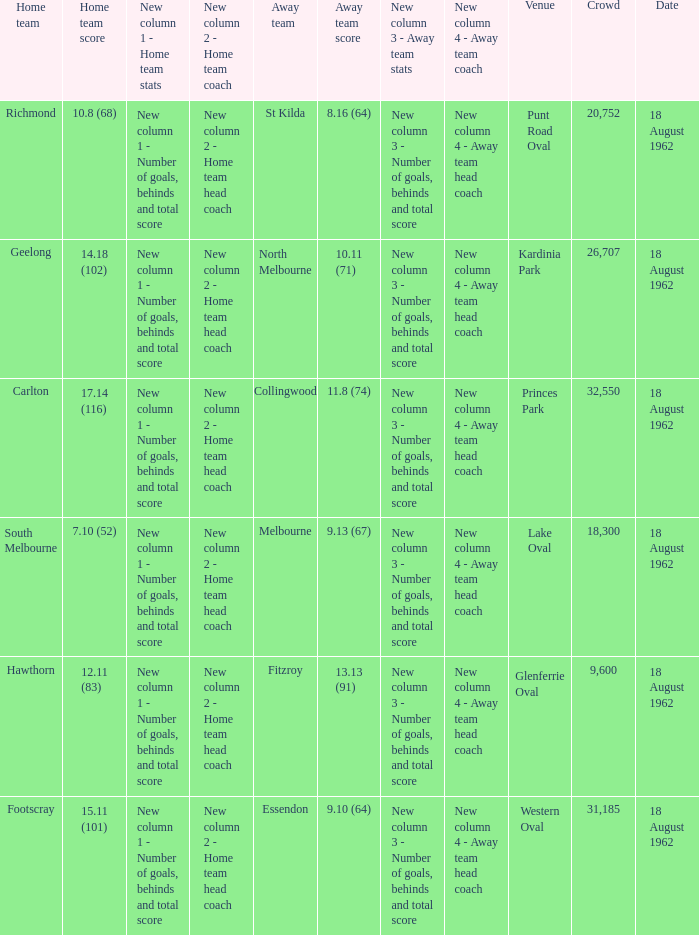What was the domestic team when the opponent team scored Footscray. 